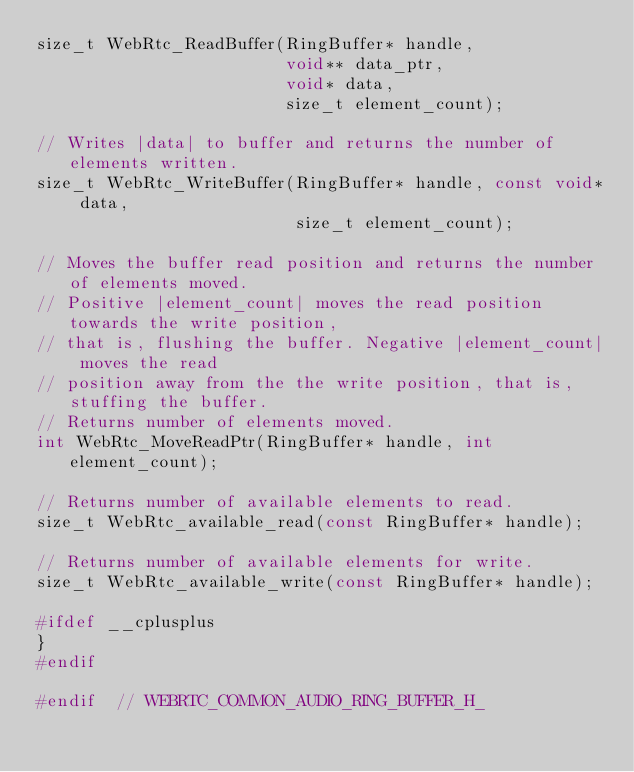Convert code to text. <code><loc_0><loc_0><loc_500><loc_500><_C_>size_t WebRtc_ReadBuffer(RingBuffer* handle,
                         void** data_ptr,
                         void* data,
                         size_t element_count);

// Writes |data| to buffer and returns the number of elements written.
size_t WebRtc_WriteBuffer(RingBuffer* handle, const void* data,
                          size_t element_count);

// Moves the buffer read position and returns the number of elements moved.
// Positive |element_count| moves the read position towards the write position,
// that is, flushing the buffer. Negative |element_count| moves the read
// position away from the the write position, that is, stuffing the buffer.
// Returns number of elements moved.
int WebRtc_MoveReadPtr(RingBuffer* handle, int element_count);

// Returns number of available elements to read.
size_t WebRtc_available_read(const RingBuffer* handle);

// Returns number of available elements for write.
size_t WebRtc_available_write(const RingBuffer* handle);

#ifdef __cplusplus
}
#endif

#endif  // WEBRTC_COMMON_AUDIO_RING_BUFFER_H_
</code> 